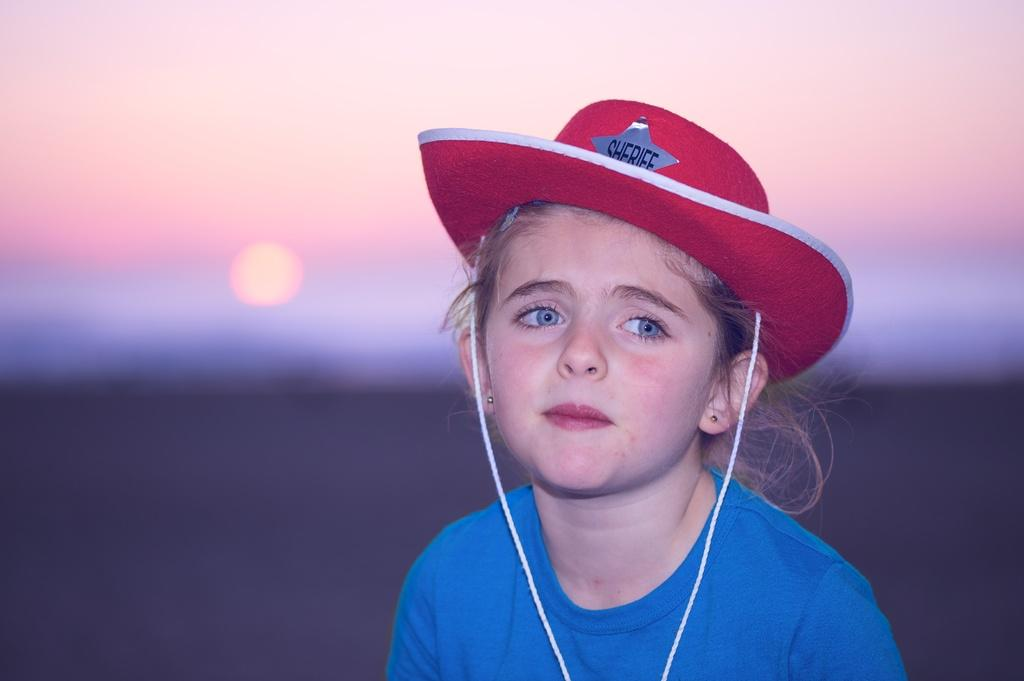Who is the main subject in the image? There is a girl in the image. What is the girl wearing on her upper body? The girl is wearing a blue T-shirt. What is the girl wearing on her head? The girl is wearing a red hat. What can be seen in the sky in the background of the image? There is a sun visible in the sky in the background of the image. What type of animal is the girl interacting with in the image? There is no animal present in the image; the girl is the only subject. 